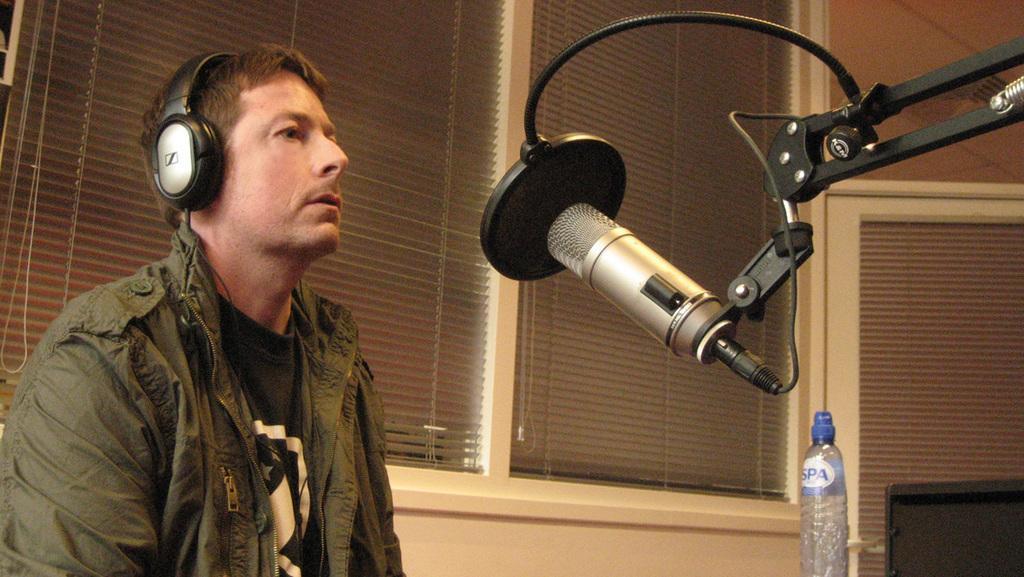Describe this image in one or two sentences. In this picture I can see a man is wearing a headset and he is sitting and I can see a microphone to the stand and I can see a water bottle and another chair on the right side and I can see blinds to the window. 